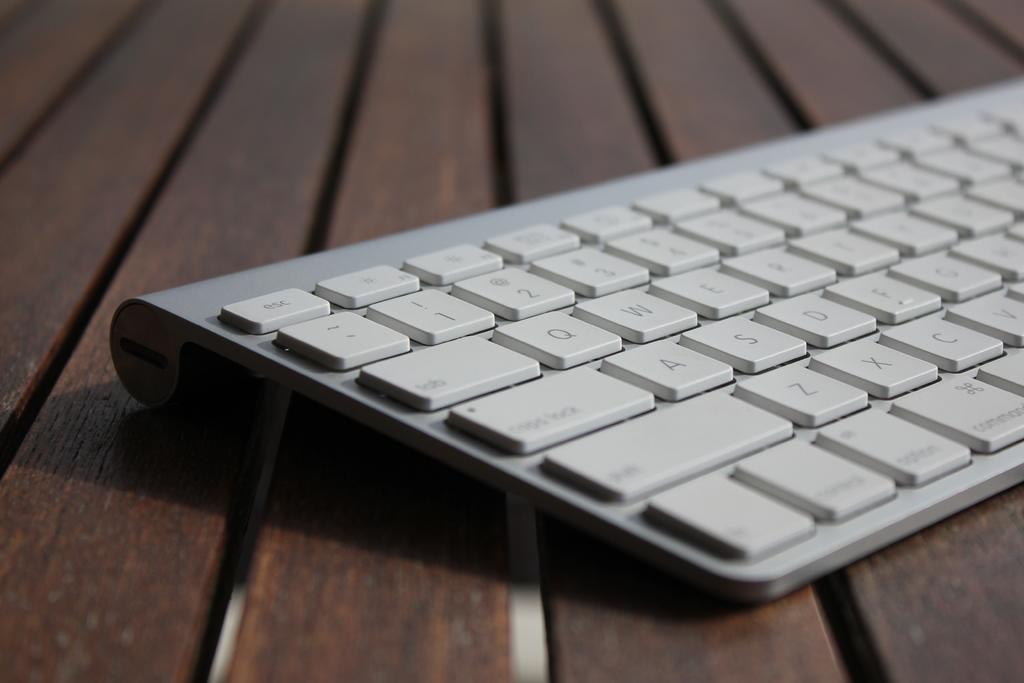Is there a caps lock key on the keyboard?
Give a very brief answer. Yes. 